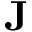Convert formula to latex. <formula><loc_0><loc_0><loc_500><loc_500>{ J }</formula> 